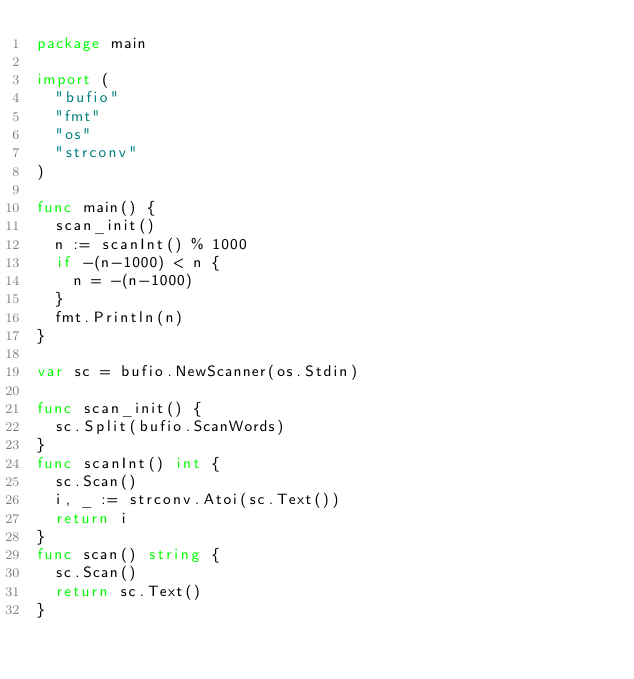Convert code to text. <code><loc_0><loc_0><loc_500><loc_500><_Go_>package main

import (
	"bufio"
	"fmt"
	"os"
	"strconv"
)

func main() {
	scan_init()
	n := scanInt() % 1000
	if -(n-1000) < n {
		n = -(n-1000)
	}
	fmt.Println(n)
}

var sc = bufio.NewScanner(os.Stdin)

func scan_init() {
	sc.Split(bufio.ScanWords)
}
func scanInt() int {
	sc.Scan()
	i, _ := strconv.Atoi(sc.Text())
	return i
}
func scan() string {
	sc.Scan()
	return sc.Text()
}
</code> 